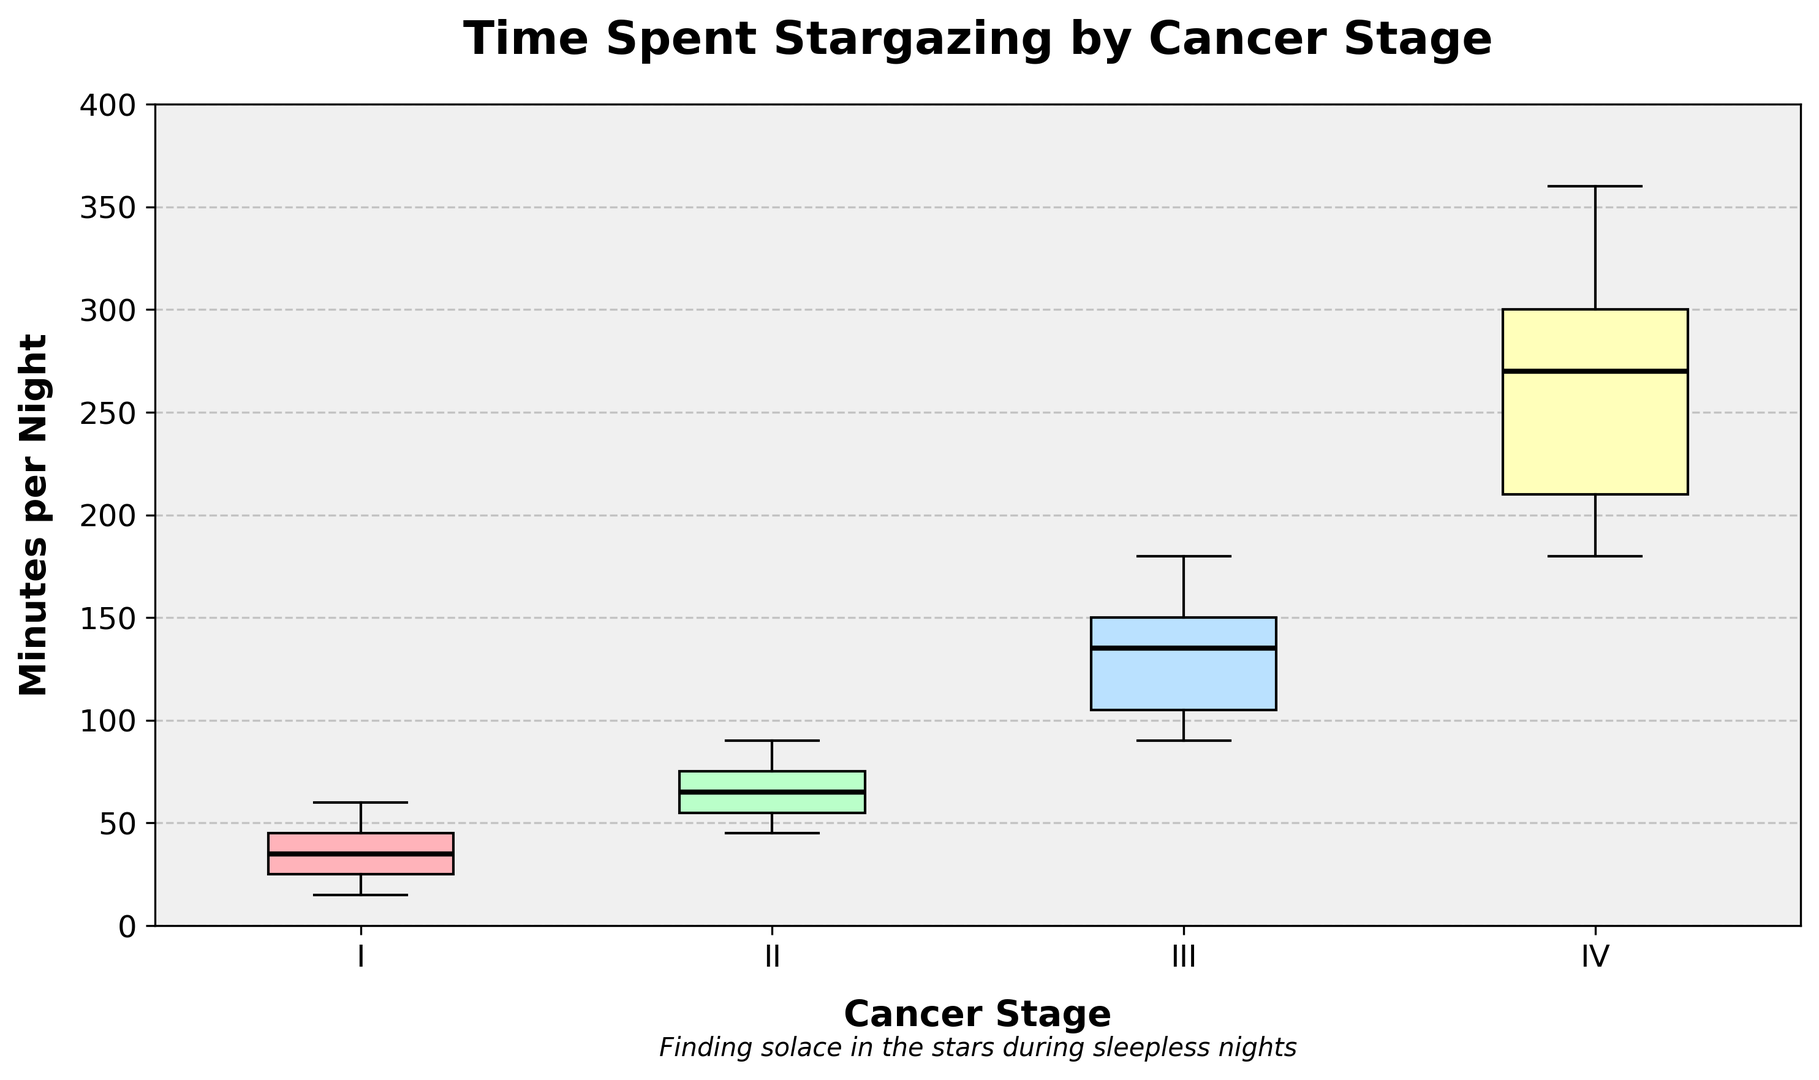What's the median time spent stargazing by patients in Stage I? The median value for Stage I can be seen as the middle value of the data points in the box plot, which is visually represented by the thick black line inside the box. For Stage I, identify this line within the box.
Answer: 32.5 What is the interquartile range (IQR) for the time spent stargazing by patients in Stage IV? The IQR is the range between the first quartile (Q1) and the third quartile (Q3), represented by the box's bottom and top edges, respectively. For Stage IV, identify the values at these edges and subtract Q1 from Q3.
Answer: 255 Which stage has the highest median time spent stargazing? Check the black lines in the center of each box plot. The stage with the line at the highest position has the highest median value.
Answer: IV How does the spread of the data for Stage III compare to Stage I? Observe the range from the minimum to the maximum value (whiskers) and the box length in each stage. Compare the visual span of these elements between Stage III and Stage I.
Answer: Much wider spread Are there any outliers in the time spent stargazing for Stage I patients? Outliers are represented as dots outside the whiskers. Check if there are any dots beyond the whiskers for the Stage I plot.
Answer: No 